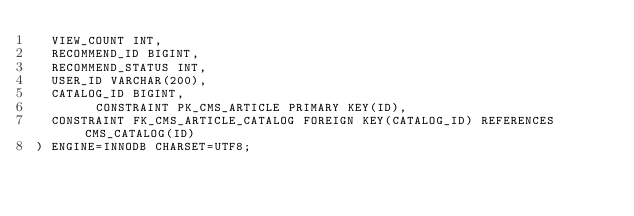<code> <loc_0><loc_0><loc_500><loc_500><_SQL_>	VIEW_COUNT INT,
	RECOMMEND_ID BIGINT,
	RECOMMEND_STATUS INT,
	USER_ID VARCHAR(200),
	CATALOG_ID BIGINT,
        CONSTRAINT PK_CMS_ARTICLE PRIMARY KEY(ID),
	CONSTRAINT FK_CMS_ARTICLE_CATALOG FOREIGN KEY(CATALOG_ID) REFERENCES CMS_CATALOG(ID)
) ENGINE=INNODB CHARSET=UTF8;

</code> 